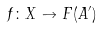Convert formula to latex. <formula><loc_0><loc_0><loc_500><loc_500>f \colon X \to F ( A ^ { \prime } )</formula> 